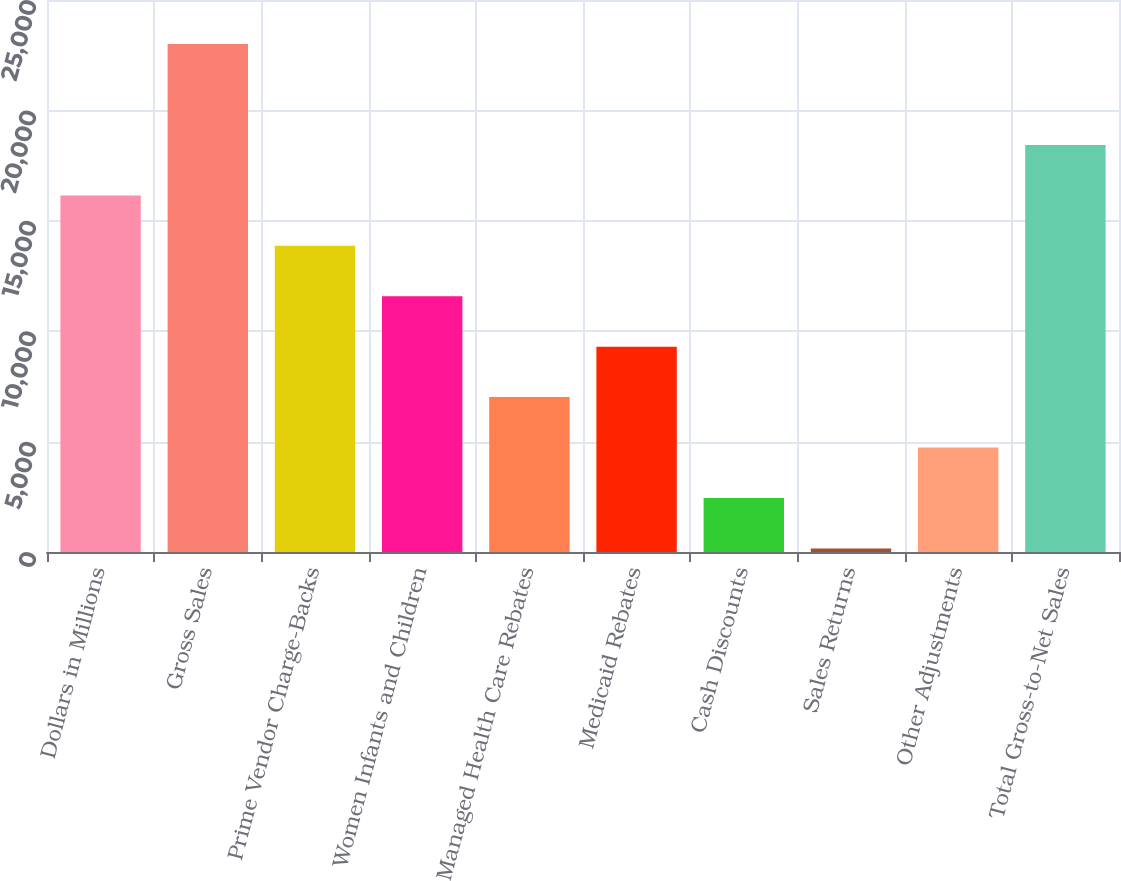Convert chart. <chart><loc_0><loc_0><loc_500><loc_500><bar_chart><fcel>Dollars in Millions<fcel>Gross Sales<fcel>Prime Vendor Charge-Backs<fcel>Women Infants and Children<fcel>Managed Health Care Rebates<fcel>Medicaid Rebates<fcel>Cash Discounts<fcel>Sales Returns<fcel>Other Adjustments<fcel>Total Gross-to-Net Sales<nl><fcel>16151.3<fcel>23003<fcel>13867.4<fcel>11583.5<fcel>7015.7<fcel>9299.6<fcel>2447.9<fcel>164<fcel>4731.8<fcel>18435.2<nl></chart> 